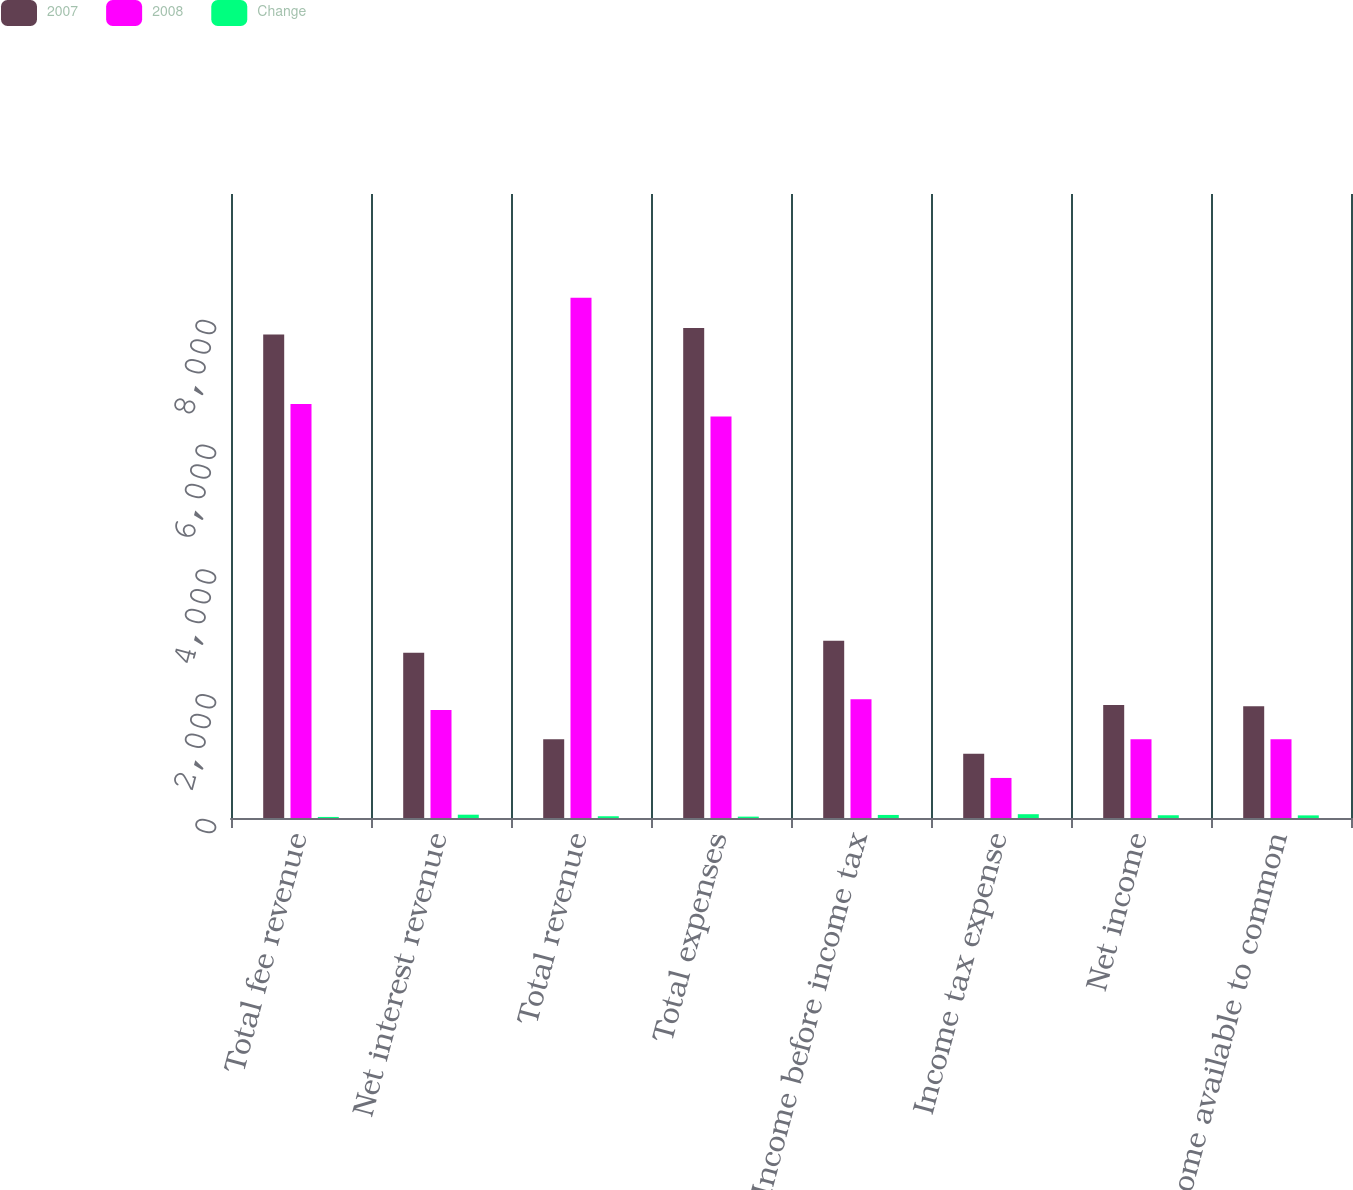Convert chart to OTSL. <chart><loc_0><loc_0><loc_500><loc_500><stacked_bar_chart><ecel><fcel>Total fee revenue<fcel>Net interest revenue<fcel>Total revenue<fcel>Total expenses<fcel>Income before income tax<fcel>Income tax expense<fcel>Net income<fcel>Net income available to common<nl><fcel>2007<fcel>7747<fcel>2650<fcel>1261<fcel>7851<fcel>2842<fcel>1031<fcel>1811<fcel>1789<nl><fcel>2008<fcel>6633<fcel>1730<fcel>8336<fcel>6433<fcel>1903<fcel>642<fcel>1261<fcel>1261<nl><fcel>Change<fcel>17<fcel>53<fcel>28<fcel>22<fcel>49<fcel>61<fcel>44<fcel>42<nl></chart> 